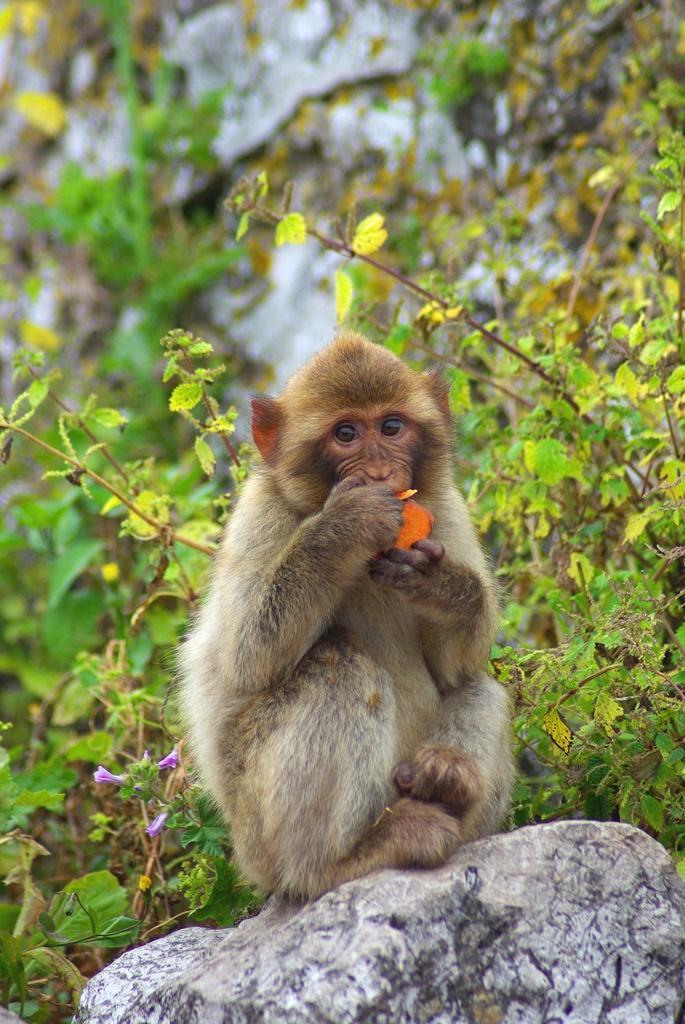How would you summarize this image in a sentence or two? This picture is clicked outside. In the foreground there is a monkey sitting on the rock and eating some food. In the background we can see the plants and the rocks. 